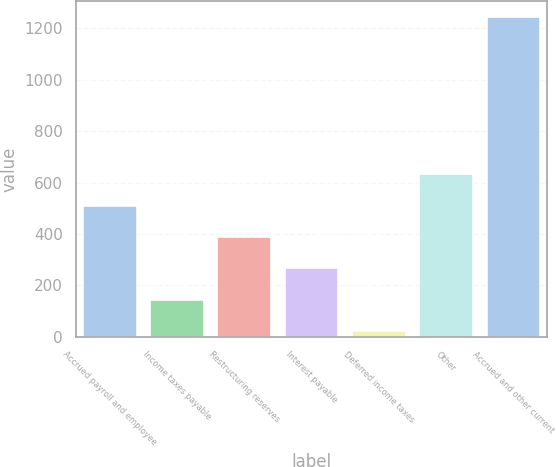Convert chart. <chart><loc_0><loc_0><loc_500><loc_500><bar_chart><fcel>Accrued payroll and employee<fcel>Income taxes payable<fcel>Restructuring reserves<fcel>Interest payable<fcel>Deferred income taxes<fcel>Other<fcel>Accrued and other current<nl><fcel>510.4<fcel>144.1<fcel>388.3<fcel>266.2<fcel>22<fcel>632.5<fcel>1243<nl></chart> 